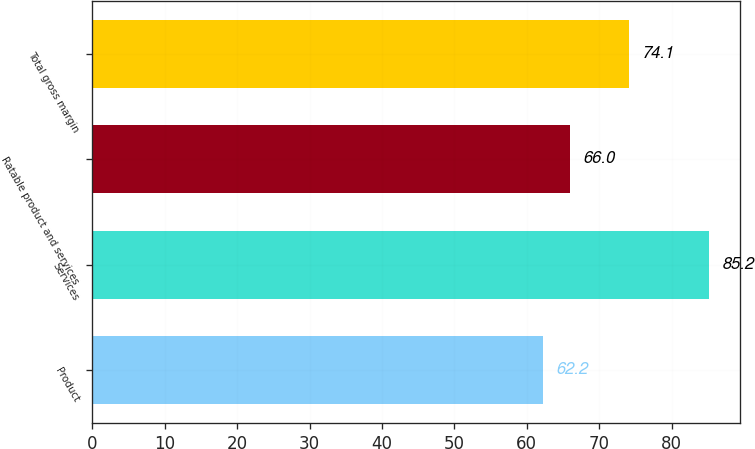Convert chart to OTSL. <chart><loc_0><loc_0><loc_500><loc_500><bar_chart><fcel>Product<fcel>Services<fcel>Ratable product and services<fcel>Total gross margin<nl><fcel>62.2<fcel>85.2<fcel>66<fcel>74.1<nl></chart> 